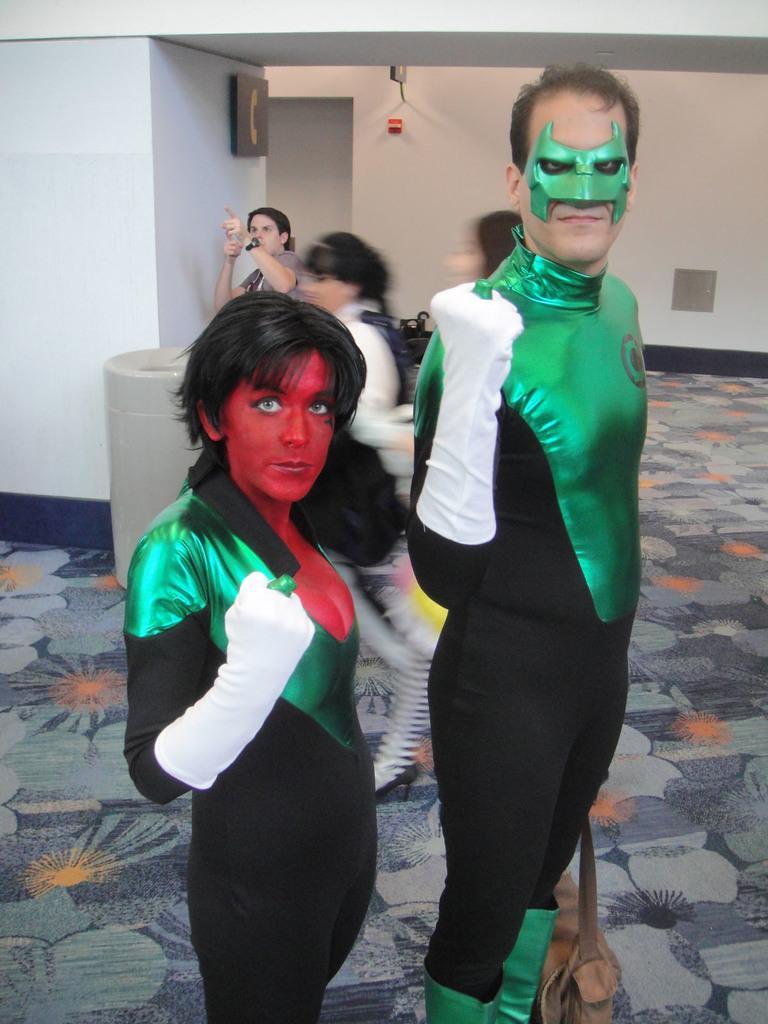Describe this image in one or two sentences. In this picture I can see two persons in the middle, they are wearing the costumes, in the background few persons are walking and there are walls, on the left side there is a board. 